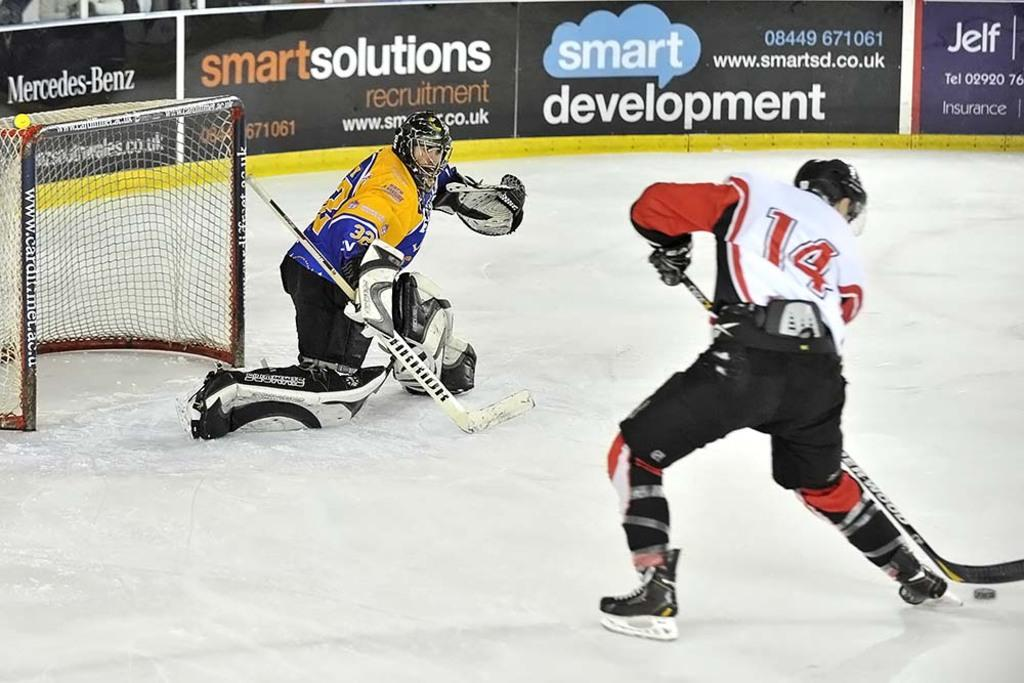What are the two persons in the image doing? The two persons in the image are playing snow hockey. What is used to mark the goal in the game? There is a net with poles in the image, which is used to mark the goal. What else can be seen in the image besides the snow hockey game? There are posters visible in the image. How does the body of the snow react to the laughter in the image? There is no laughter present in the image, and the snow is not a body that can react to emotions. 